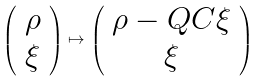Convert formula to latex. <formula><loc_0><loc_0><loc_500><loc_500>\left ( \begin{array} { c } \rho \\ \xi \end{array} \right ) \mapsto \left ( \begin{array} { c } \rho - Q C \xi \\ \xi \end{array} \right )</formula> 